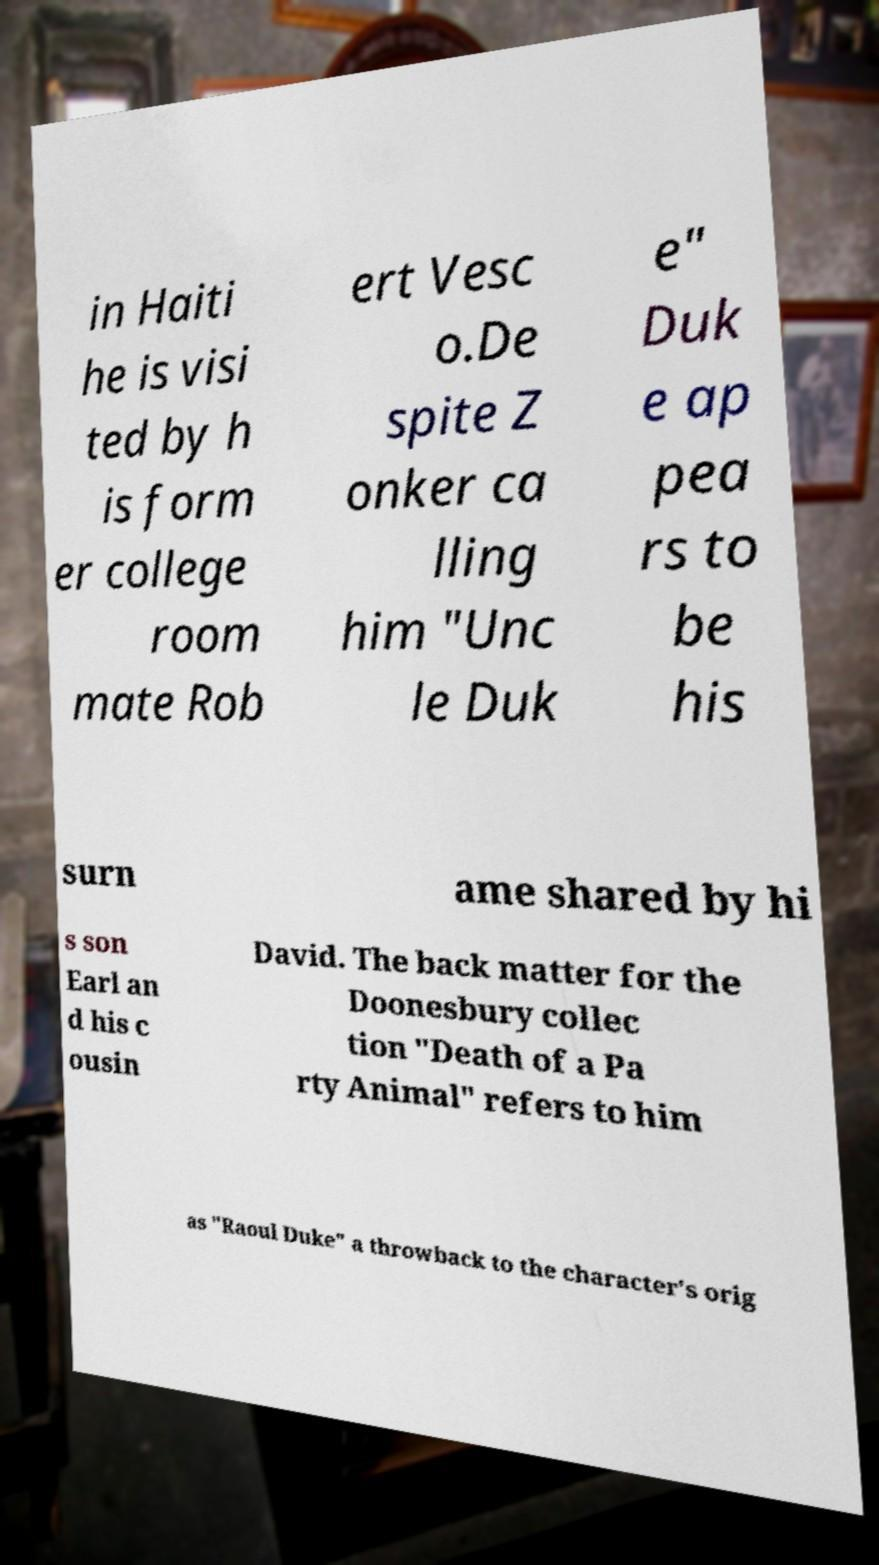I need the written content from this picture converted into text. Can you do that? in Haiti he is visi ted by h is form er college room mate Rob ert Vesc o.De spite Z onker ca lling him "Unc le Duk e" Duk e ap pea rs to be his surn ame shared by hi s son Earl an d his c ousin David. The back matter for the Doonesbury collec tion "Death of a Pa rty Animal" refers to him as "Raoul Duke" a throwback to the character's orig 